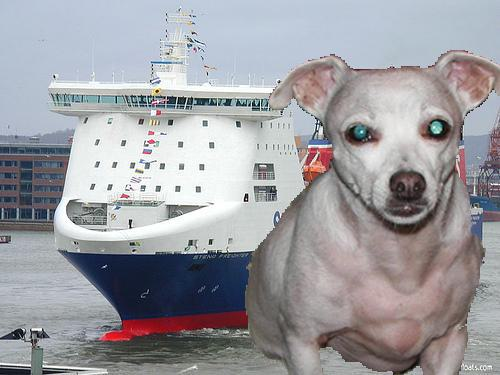Is this an image of a real scene? No, this image is not a depiction of a real scene. It has been altered through digital means, combining elements such as the dog and the ferry in an unrealistic manner. 